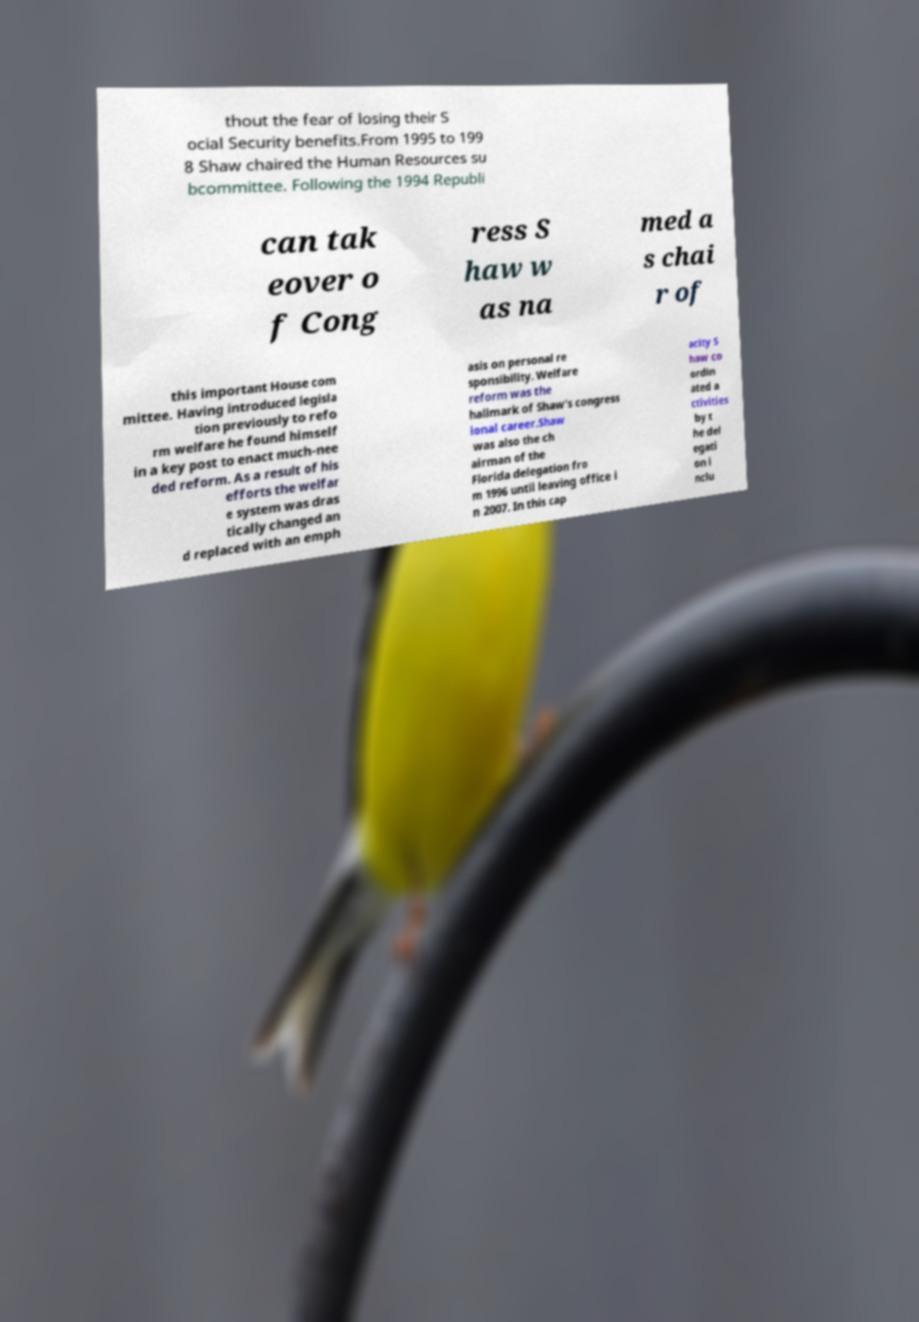Please identify and transcribe the text found in this image. thout the fear of losing their S ocial Security benefits.From 1995 to 199 8 Shaw chaired the Human Resources su bcommittee. Following the 1994 Republi can tak eover o f Cong ress S haw w as na med a s chai r of this important House com mittee. Having introduced legisla tion previously to refo rm welfare he found himself in a key post to enact much-nee ded reform. As a result of his efforts the welfar e system was dras tically changed an d replaced with an emph asis on personal re sponsibility. Welfare reform was the hallmark of Shaw's congress ional career.Shaw was also the ch airman of the Florida delegation fro m 1996 until leaving office i n 2007. In this cap acity S haw co ordin ated a ctivities by t he del egati on i nclu 